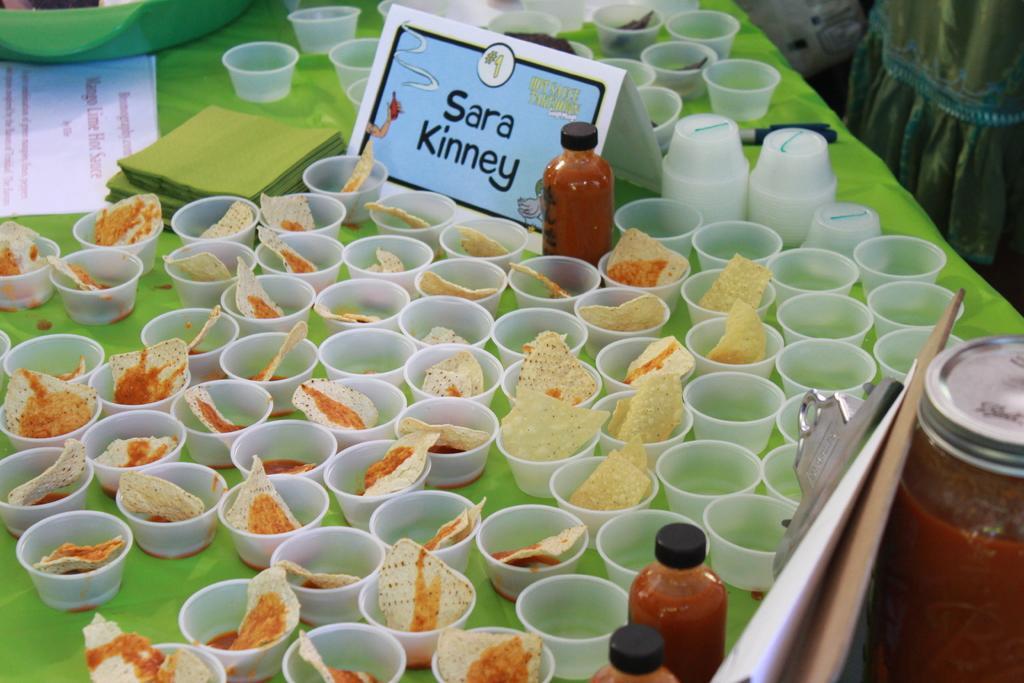How would you summarize this image in a sentence or two? There is a table. On the table there is a green cloth. Also there are many cups. Inside the cups there are some food items. On the table there are bottles, a name plate and papers. 